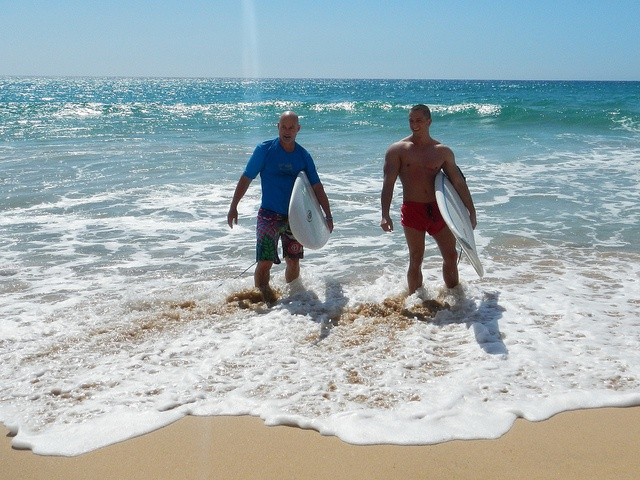Describe the objects in this image and their specific colors. I can see people in lightblue, maroon, black, gray, and darkgray tones, people in lightblue, navy, black, maroon, and gray tones, surfboard in lightblue, gray, and darkgray tones, and surfboard in lightblue, darkgray, gray, and lightgray tones in this image. 